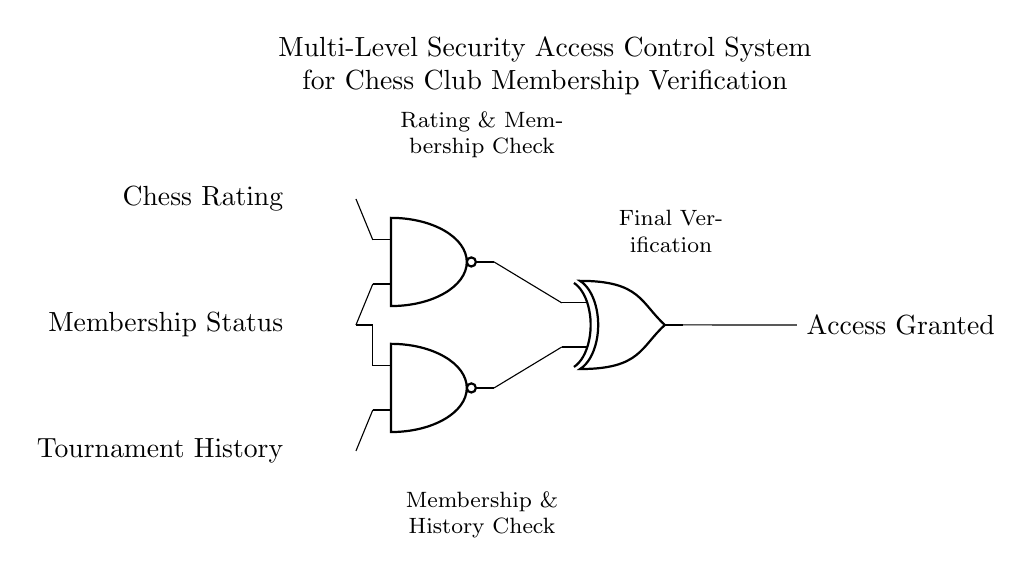What type of logic gates are used in this circuit? The circuit uses NAND and XOR gates, which can be identified by their symbols in the diagram. The top two gates are labeled as NAND, while the gate on the right is labeled as XOR.
Answer: NAND and XOR What is the role of the first NAND gate? The first NAND gate combines the inputs of Chess Rating and Membership Status to perform a logical operation. Its output is essential for the subsequent processing in the circuit.
Answer: Checking Rating and Membership How many inputs does the XOR gate have? The XOR gate in the diagram has two inputs, as shown by the two lines connecting to it from the NAND gates.
Answer: Two What would be the output if both inputs to the NAND gate are true? If both inputs to a NAND gate are true, the output will be false. The NAND gate produces a false output only when all its inputs are true.
Answer: False What is the final output of the circuit? The final output, labeled as Access Granted, indicates whether access is granted based on the logic operations performed by the gates in the circuit.
Answer: Access Granted How does the output of the NAND gates affect the XOR gate? The outputs of the NAND gates serve as the inputs to the XOR gate. Their logical states determine the final output of the circuit, as XOR outputs true only when one input is true and the other is false.
Answer: Logical condition of NAND outputs What checks are performed by the second NAND gate? The second NAND gate checks the Membership Status and Tournament History. This is shown by the connections leading to it from these two inputs.
Answer: Checking Membership and History 